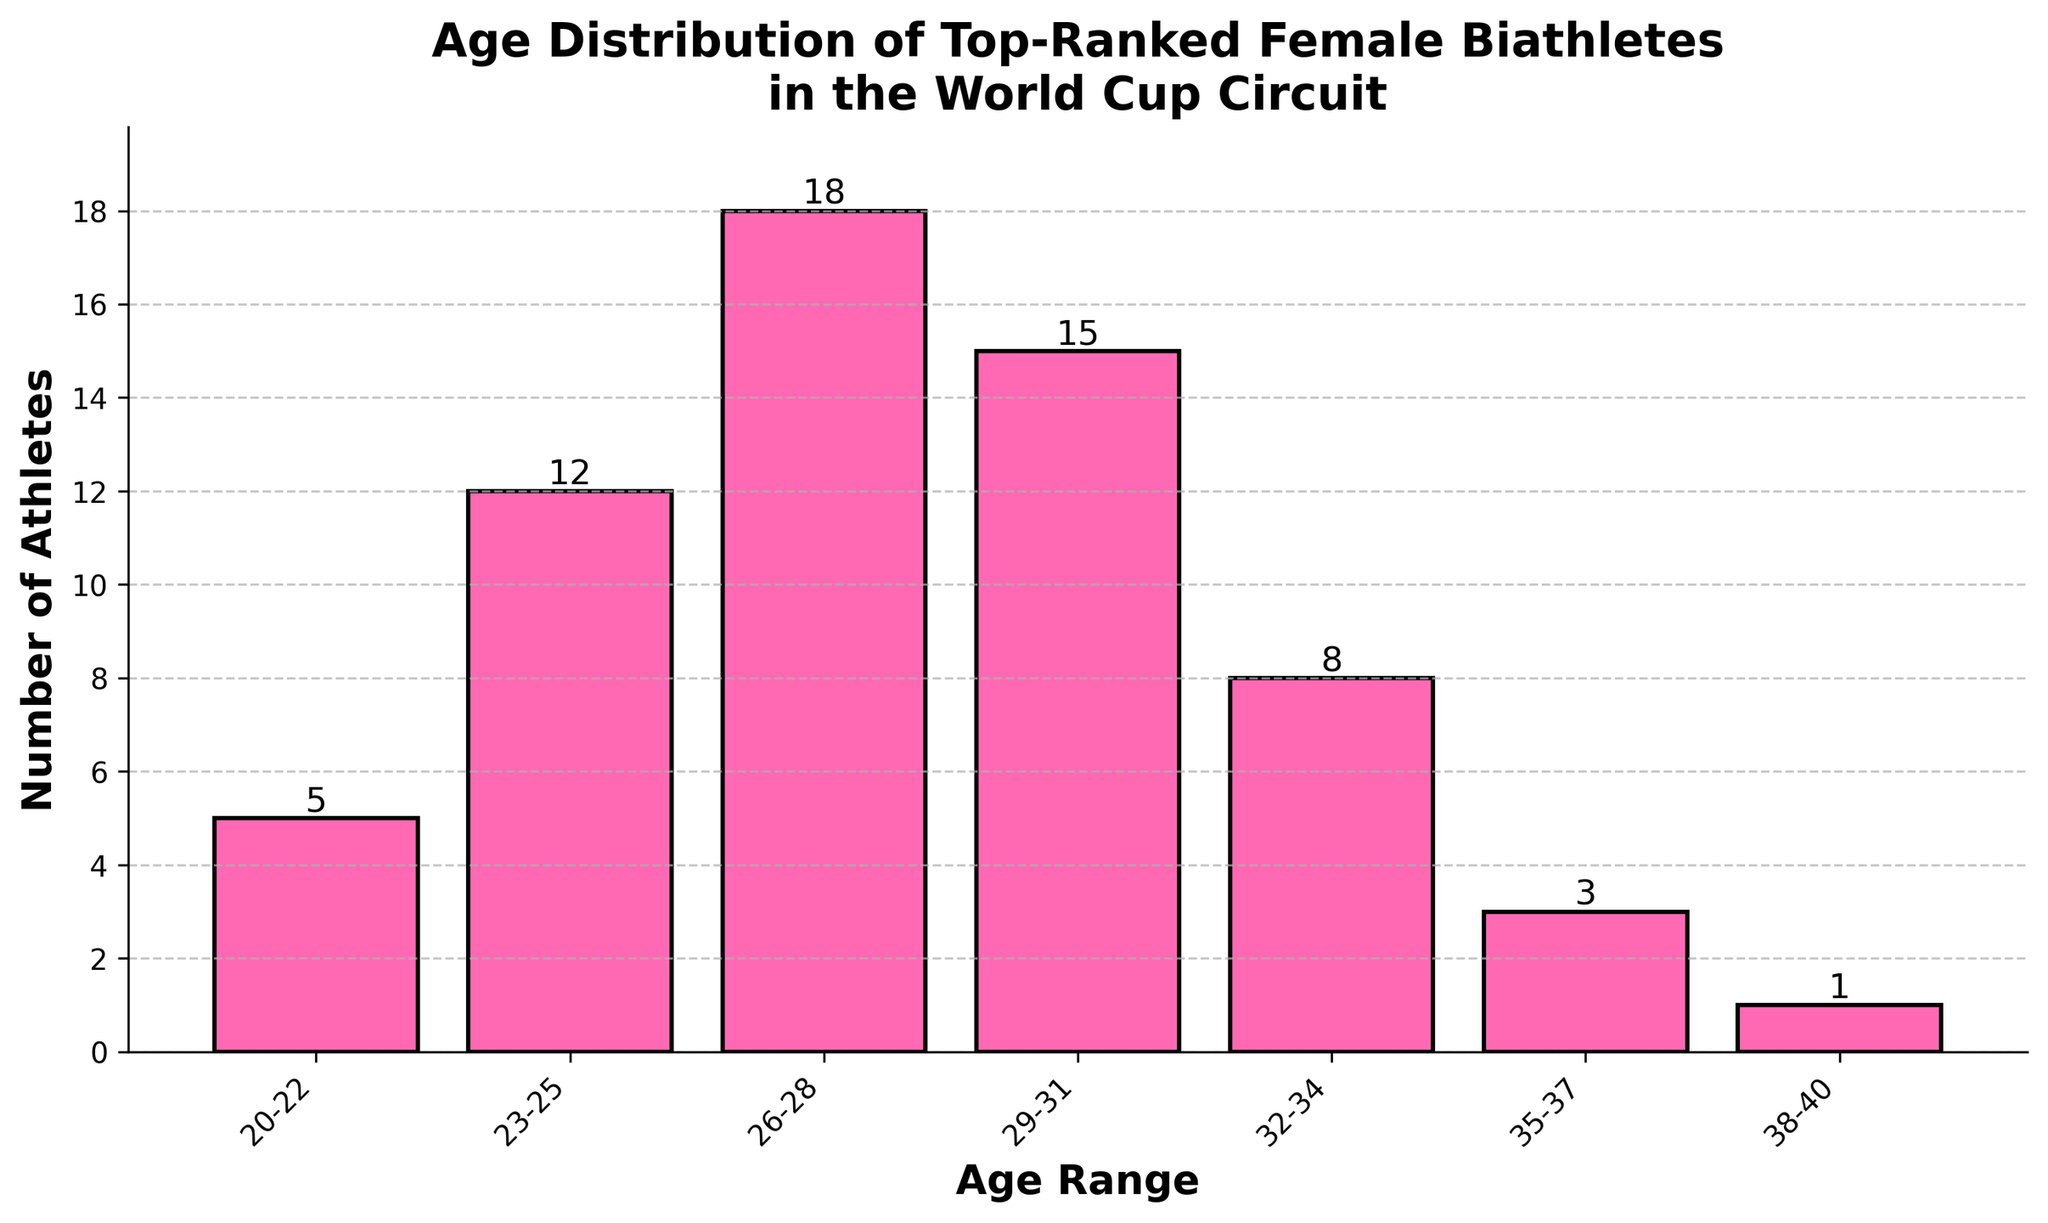What is the age range with the highest number of top-ranked female biathletes? This can be answered by visually identifying the highest bar. The tallest bar corresponds to the age range 26-28.
Answer: 26-28 Which age range has the smallest representation among top-ranked female biathletes? This can be found by identifying the shortest bar in the chart. The shortest bar corresponds to the age range 38-40.
Answer: 38-40 How many athletes are in the age ranges 20-22 and 35-37 combined? Add the number of athletes in the 20-22 and 35-37 age ranges: 5 (20-22) + 3 (35-37) = 8.
Answer: 8 Compare the number of athletes between the age ranges 26-28 and 29-31. Which age range has more athletes, and by how many? The 26-28 age range has 18 athletes, and the 29-31 age range has 15 athletes. Subtract 15 from 18 to find the difference: 18 - 15 = 3.
Answer: 26-28, by 3 What is the total number of top-ranked female biathletes in the World Cup circuit as depicted in the chart? Add up the number of athletes in all age ranges: 5 (20-22) + 12 (23-25) + 18 (26-28) + 15 (29-31) + 8 (32-34) + 3 (35-37) + 1 (38-40) = 62.
Answer: 62 What proportion of the athletes are in the age range 26-28 relative to the total number of athletes? The total number of athletes is 62 and 18 of them are in the age range 26-28. Divide 18 by 62 and multiply by 100 to get the percentage: (18/62) * 100 ≈ 29.03%.
Answer: 29.03% How does the number of athletes in the age range 32-34 compare to the number in the age range 35-37? The age range 32-34 has 8 athletes, while the age range 35-37 has 3 athletes. Subtract 3 from 8 to find the difference: 8 - 3 = 5.
Answer: 5 more athletes in 32-34 Which age ranges have more than 10 athletes each? Identify bars taller than 10: The age ranges 23-25 (12), 26-28 (18), and 29-31 (15) all have more than 10 athletes.
Answer: 23-25, 26-28, 29-31 What is the average number of athletes per age range? Divide the total number of athletes by the number of age ranges: 62 athletes / 7 age ranges ≈ 8.86 athletes.
Answer: 8.86 